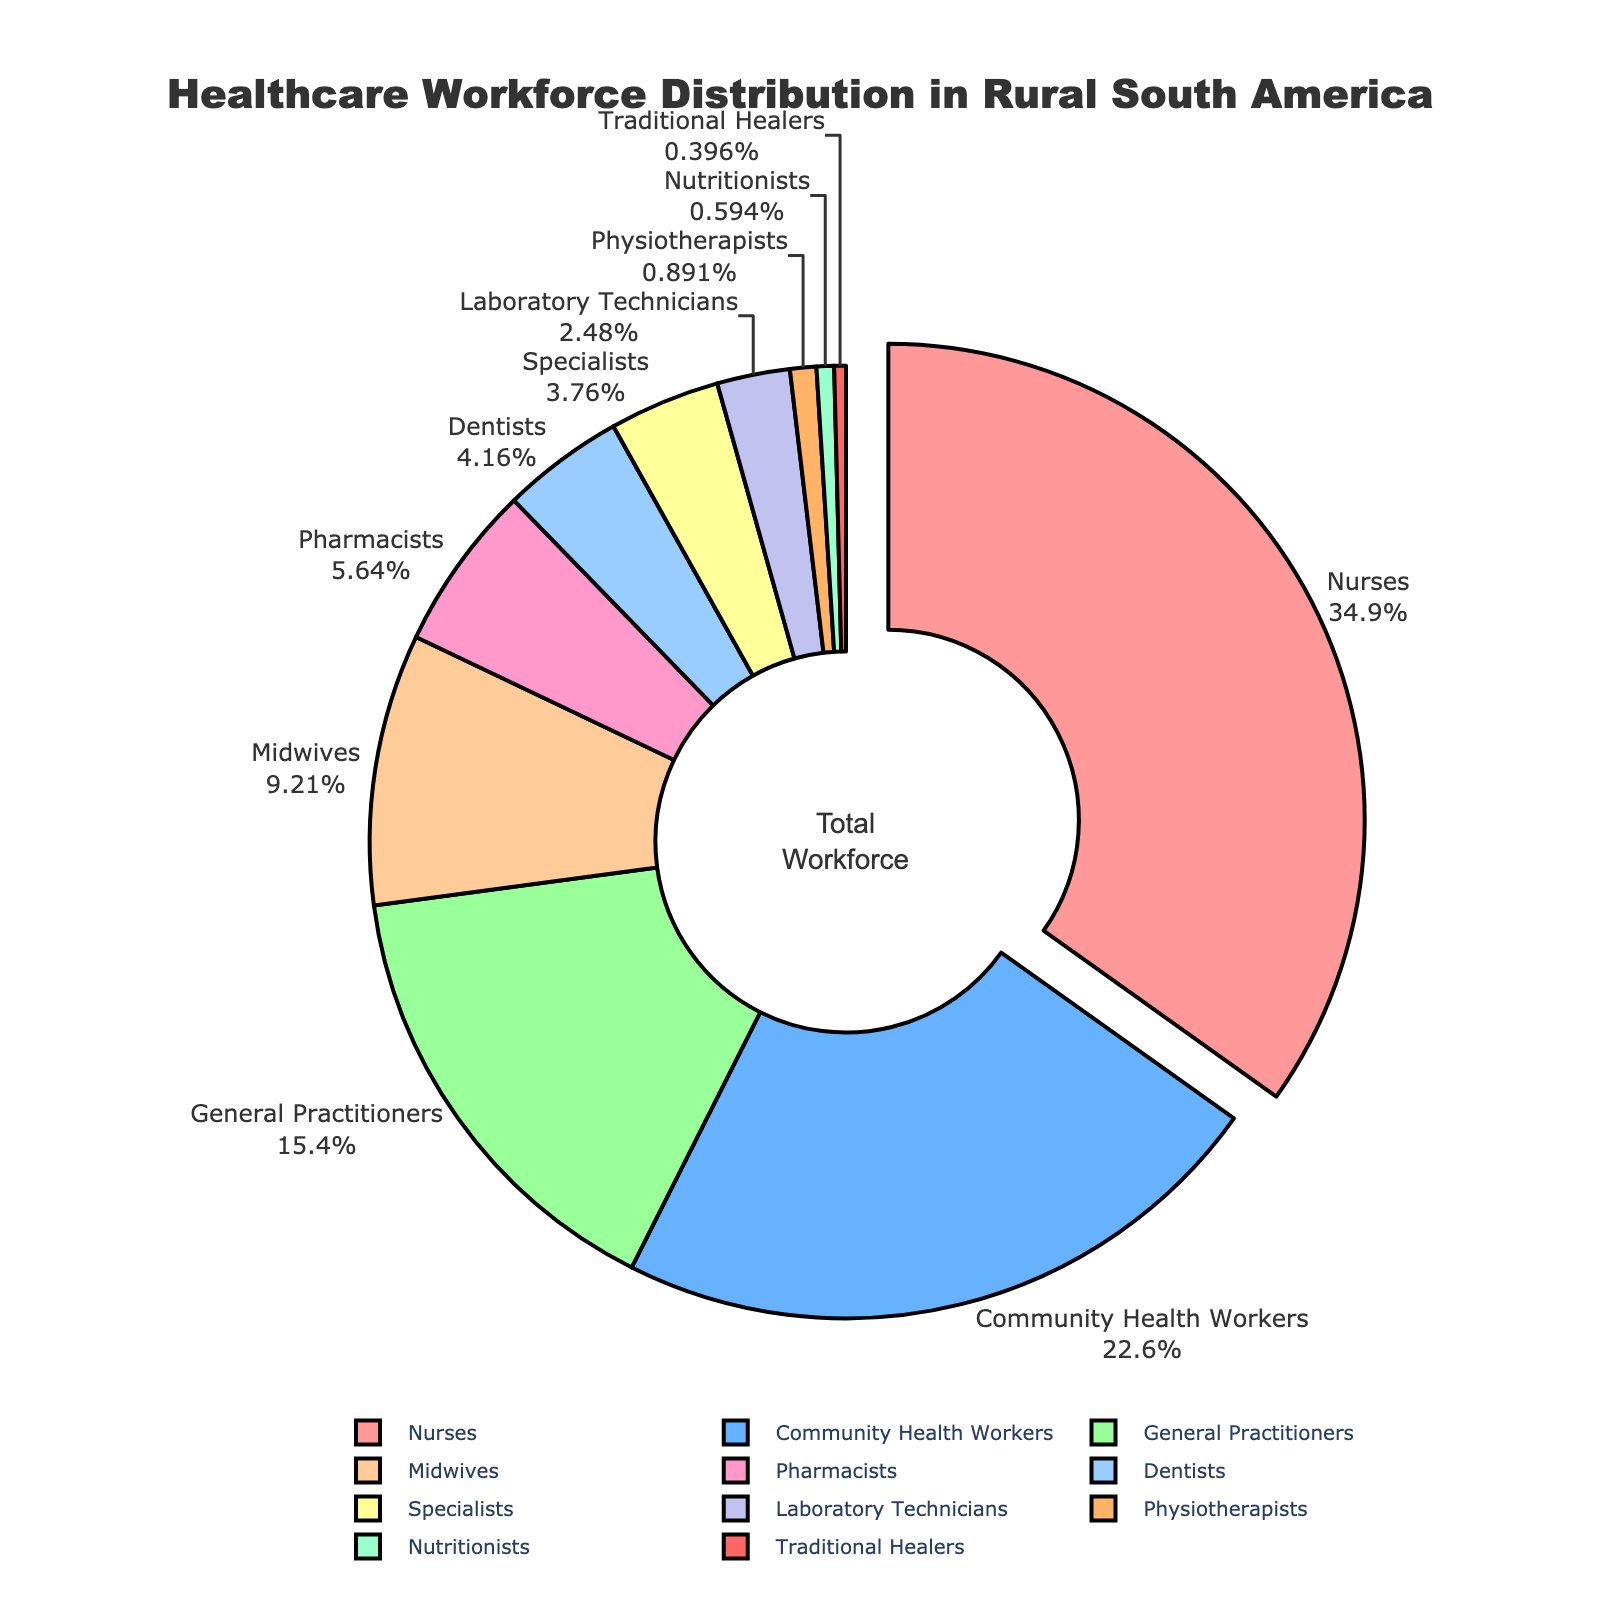What profession makes up the largest proportion of the healthcare workforce? The figure shows that nurses make up the largest proportion of the healthcare workforce, which is highlighted by the slice pulled out from the pie.
Answer: Nurses What is the combined percentage of General Practitioners and Specialists? To find the combined percentage, add the percentages of General Practitioners (15.6%) and Specialists (3.8%). 15.6% + 3.8% = 19.4%
Answer: 19.4% How does the proportion of Nurses compare to the combined proportion of Midwives and Pharmacists? The proportion of Nurses is 35.2%. The combined proportion of Midwives (9.3%) and Pharmacists (5.7%) is 9.3% + 5.7% = 15%. So, 35.2% is greater than 15%.
Answer: Greater Which profession has the smallest representation in the workforce? The figure shows that Traditional Healers have the smallest slice of the pie, representing 0.4%.
Answer: Traditional Healers What is the percentage difference between Community Health Workers and Dentists? Subtract the percentage of Dentists (4.2%) from the percentage of Community Health Workers (22.8%). 22.8% - 4.2% = 18.6%
Answer: 18.6% What is the average percentage of Pharmacists, Dentists, and Physiotherapists? Add the percentages of Pharmacists (5.7%), Dentists (4.2%), and Physiotherapists (0.9%), then divide by 3. (5.7% + 4.2% + 0.9%) / 3 = 10.8% / 3 = 3.6%
Answer: 3.6% Compare the sum of percentages of General Practitioners, Midwives, and Nutritionists to 25%. Calculate the total percentage of General Practitioners (15.6%), Midwives (9.3%), and Nutritionists (0.6%). 15.6% + 9.3% + 0.6% = 25.5%. 25.5% is greater than 25%.
Answer: Greater What color is used to represent Nurses in the pie chart? The largest section of the pie chart, representing Nurses, is colored in light red.
Answer: Light red How many professions have a representation greater than 10% in the workforce? Identify the slices with percentages above 10%. Nurses (35.2%) and Community Health Workers (22.8%) are the only ones above 10%. There are 2 professions.
Answer: 2 Which profession is represented by the light blue color in the pie chart? Light blue represents General Practitioners, which constitute 15.6% of the chart.
Answer: General Practitioners 